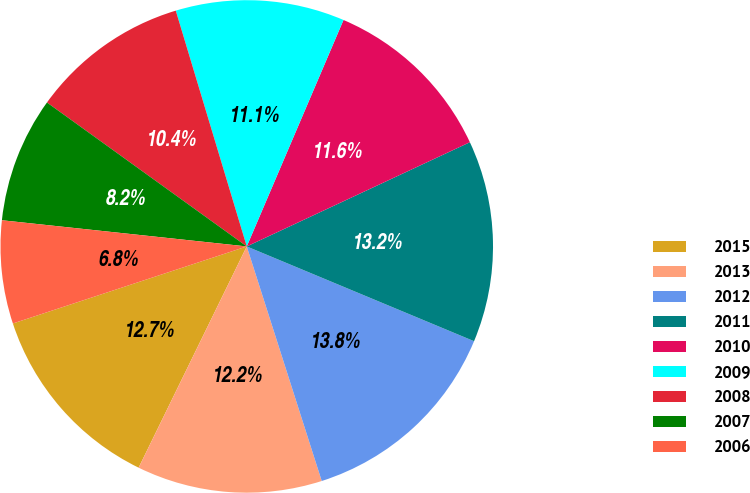Convert chart. <chart><loc_0><loc_0><loc_500><loc_500><pie_chart><fcel>2015<fcel>2013<fcel>2012<fcel>2011<fcel>2010<fcel>2009<fcel>2008<fcel>2007<fcel>2006<nl><fcel>12.7%<fcel>12.16%<fcel>13.79%<fcel>13.24%<fcel>11.62%<fcel>11.08%<fcel>10.41%<fcel>8.24%<fcel>6.76%<nl></chart> 